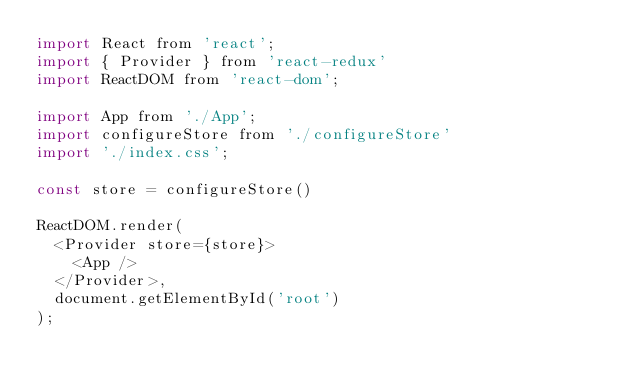Convert code to text. <code><loc_0><loc_0><loc_500><loc_500><_JavaScript_>import React from 'react';
import { Provider } from 'react-redux'
import ReactDOM from 'react-dom';

import App from './App';
import configureStore from './configureStore'
import './index.css';

const store = configureStore()

ReactDOM.render(
  <Provider store={store}>
    <App />
  </Provider>,
  document.getElementById('root')
);
</code> 